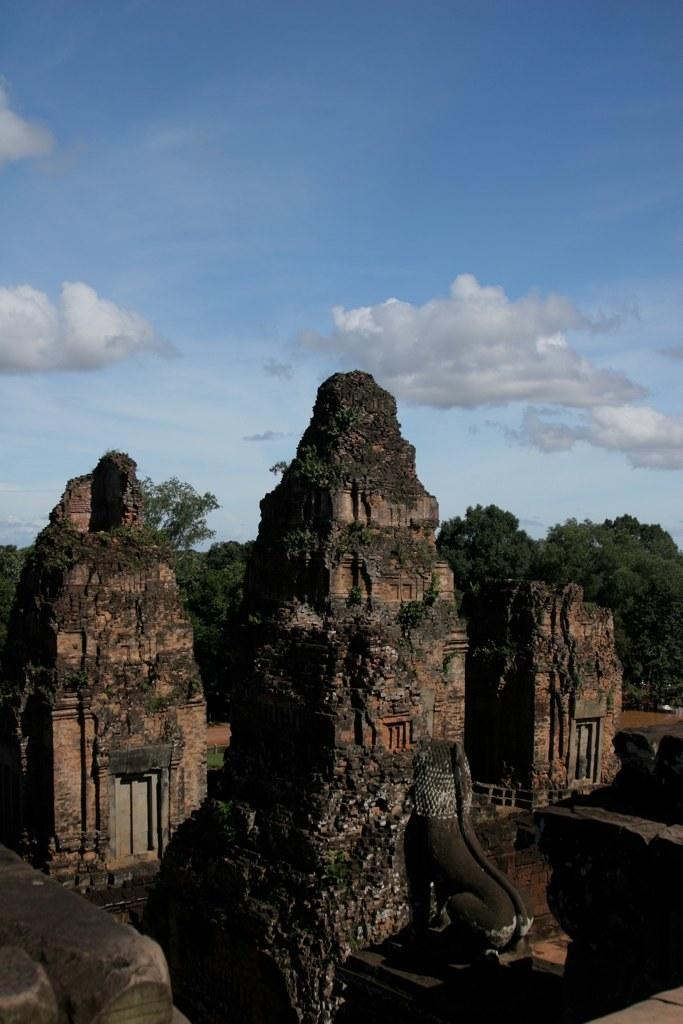What type of structures are present in the image? There are ancient architectures in the image. What other object can be seen in the image? There is a statue in the image. What can be seen in the background of the image? Trees and the sky are visible in the background of the image. Where is the manager sitting on the sofa in the image? There is no sofa or manager present in the image. What type of carriage can be seen in the image? There is no carriage present in the image. 